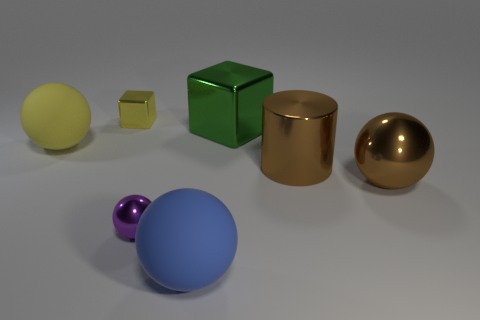Subtract all gray balls. Subtract all cyan cubes. How many balls are left? 4 Add 1 large brown things. How many objects exist? 8 Subtract all balls. How many objects are left? 3 Subtract 0 cyan cylinders. How many objects are left? 7 Subtract all purple metallic balls. Subtract all blocks. How many objects are left? 4 Add 2 brown balls. How many brown balls are left? 3 Add 5 matte spheres. How many matte spheres exist? 7 